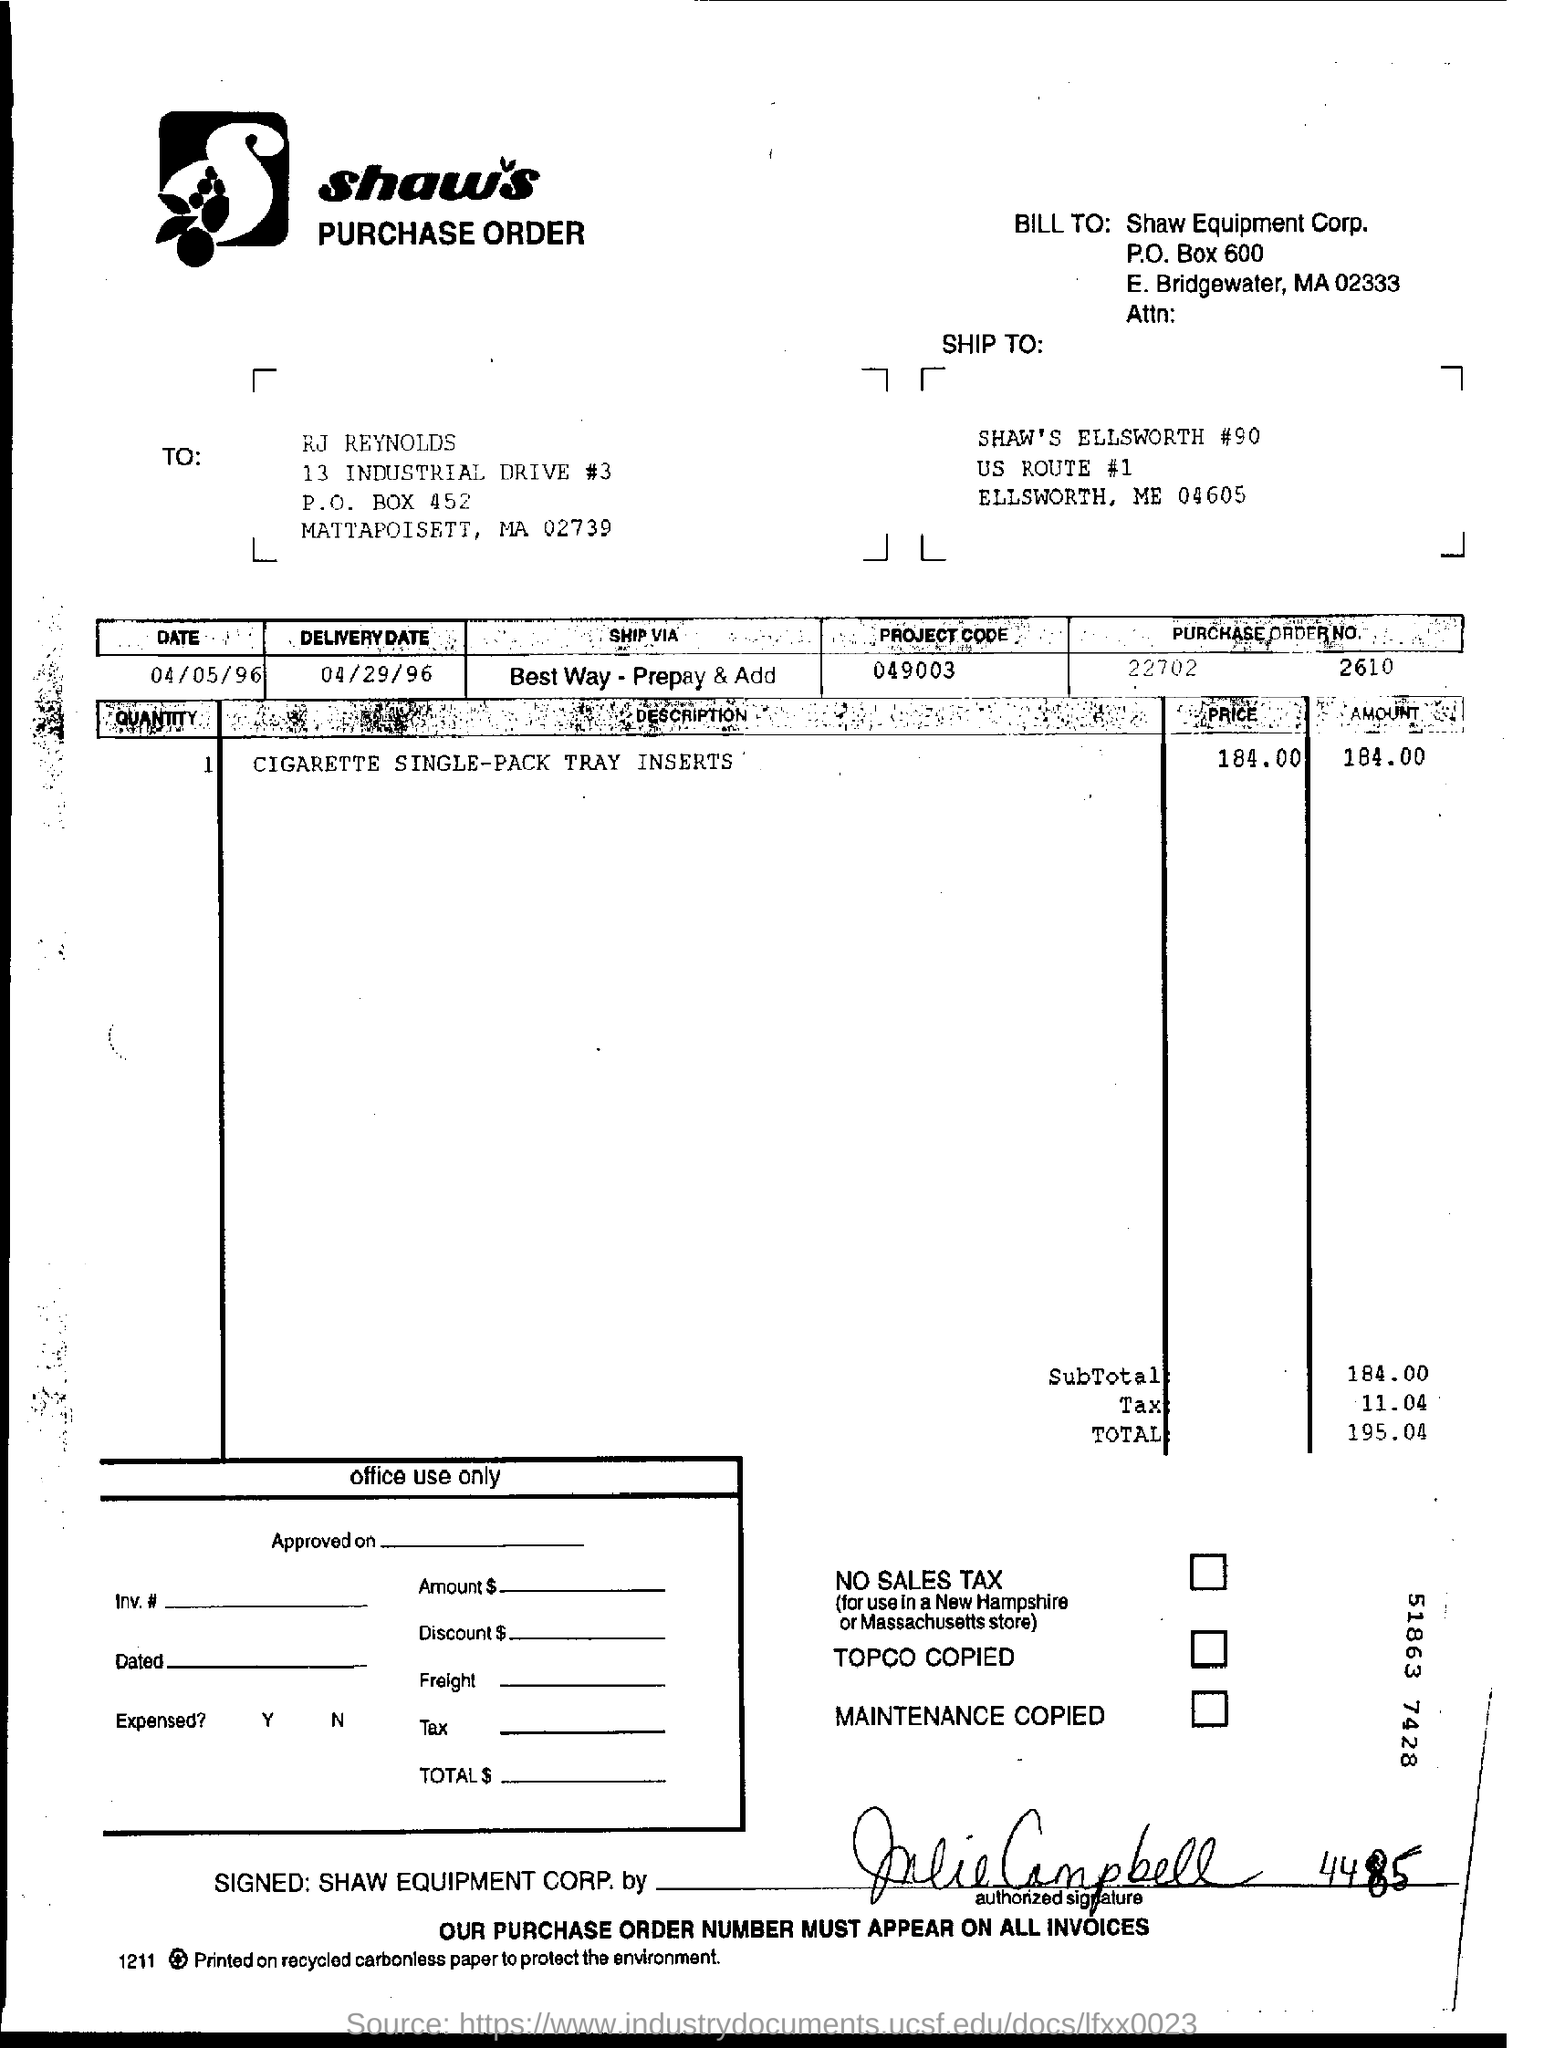What is the date of delivery?
Ensure brevity in your answer.  04/29/96. What is the project code?
Provide a short and direct response. 049003. What is the purchase order number?
Offer a very short reply. 22702      2610. How much is the subtotal?
Offer a very short reply. 184.00. What is the total amount of bill?
Provide a short and direct response. 195.04. 